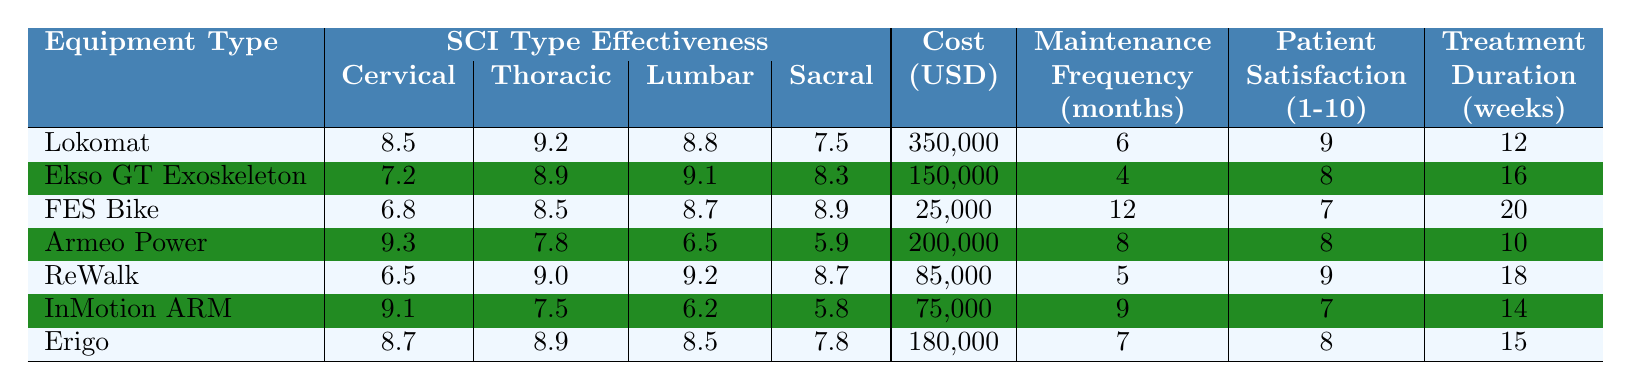What is the cost of the Lokomat? The cost is specified in the Cost (USD) column for the Lokomat row, which is 350,000.
Answer: 350,000 Which equipment has the highest patient satisfaction for cervical SCI? Looking at the Patient Satisfaction (1-10) column for cervical SCI, the Lokomat has the highest score of 8.5.
Answer: Lokomat What is the average treatment duration across all equipment types? Sum the treatment durations: (12 + 16 + 20 + 10 + 18 + 14 + 15) = 105, then divide by the number of equipment types (7), resulting in an average of 105/7 = 15.
Answer: 15 weeks Is the maintenance frequency for the Ekso GT Exoskeleton lower than that for the FES Bike? The maintenance frequency for the Ekso GT Exoskeleton is 4 months and for the FES Bike is 12 months; since 4 is less than 12, the statement is true.
Answer: Yes Which equipment has the lowest effectiveness score for lumbar SCI? The effectiveness score for lumbar SCI in the table shows that Armeo Power has the lowest score of 6.5.
Answer: Armeo Power Calculate the difference in patient satisfaction between the highest and lowest rated equipment for thoracic SCI. For thoracic SCI, Lokomat has a satisfaction of 9.2 and Armeo Power has 7.8. The difference is 9.2 - 7.8 = 1.4.
Answer: 1.4 Which equipment type shows the best effectiveness for sacral SCI? The effectiveness scores show that ReWalk has the best score of 8.7 for sacral SCI when compared with the others.
Answer: ReWalk Is the average effectiveness score for lumbar SCI greater than 8? The scores for lumbar SCI are 8.8 (Lokomat), 9.1 (Ekso GT Exoskeleton), 8.7 (FES Bike), 6.5 (Armeo Power), 9.2 (ReWalk), 6.2 (InMotion ARM), and 8.5 (Erigo). The average is (8.8 + 9.1 + 8.7 + 6.5 + 9.2 + 6.2 + 8.5) / 7 = 8.4, which is less than 8.
Answer: No What is the most cost-effective equipment type based on the price and treatment duration? Calculate the cost per treatment week for each equipment: Lokomat: 350,000/12=29,167, Ekso GT: 150,000/16=9,375, FES Bike: 25,000/20=1,250, Armeo Power: 200,000/10=20,000, ReWalk: 85,000/18=4,722, InMotion ARM: 75,000/14=5,357, Erigo: 180,000/15=12,000. The FES Bike has the lowest cost per treatment week.
Answer: FES Bike How often does the ReWalk require maintenance compared to the InMotion ARM? The ReWalk requires maintenance every 5 months, while the InMotion ARM requires it every 9 months. Since 5 is less than 9, ReWalk needs maintenance more frequently.
Answer: More frequently 